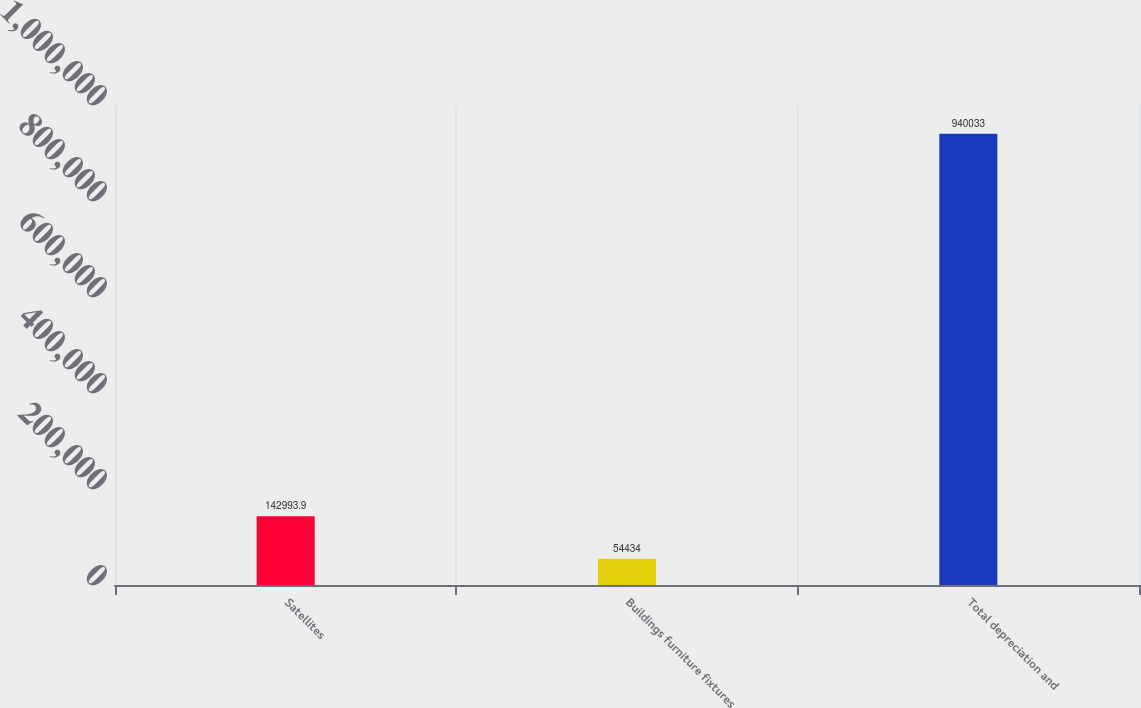<chart> <loc_0><loc_0><loc_500><loc_500><bar_chart><fcel>Satellites<fcel>Buildings furniture fixtures<fcel>Total depreciation and<nl><fcel>142994<fcel>54434<fcel>940033<nl></chart> 